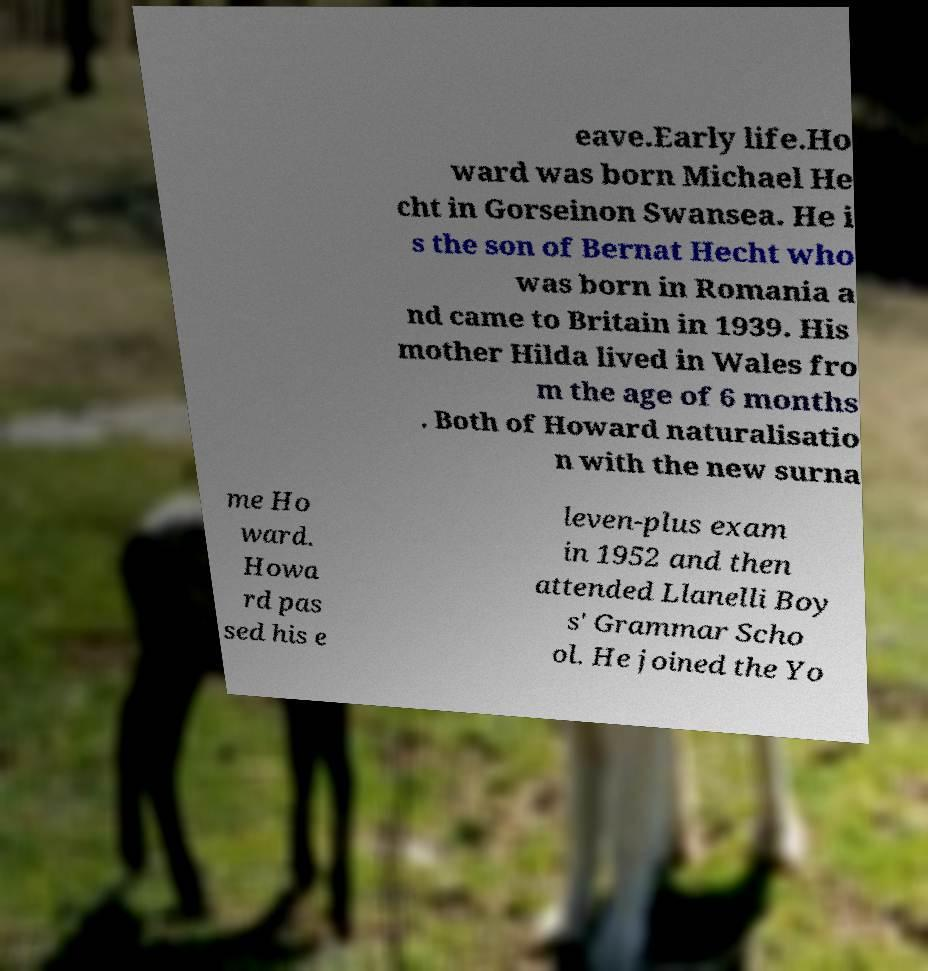Could you assist in decoding the text presented in this image and type it out clearly? eave.Early life.Ho ward was born Michael He cht in Gorseinon Swansea. He i s the son of Bernat Hecht who was born in Romania a nd came to Britain in 1939. His mother Hilda lived in Wales fro m the age of 6 months . Both of Howard naturalisatio n with the new surna me Ho ward. Howa rd pas sed his e leven-plus exam in 1952 and then attended Llanelli Boy s' Grammar Scho ol. He joined the Yo 